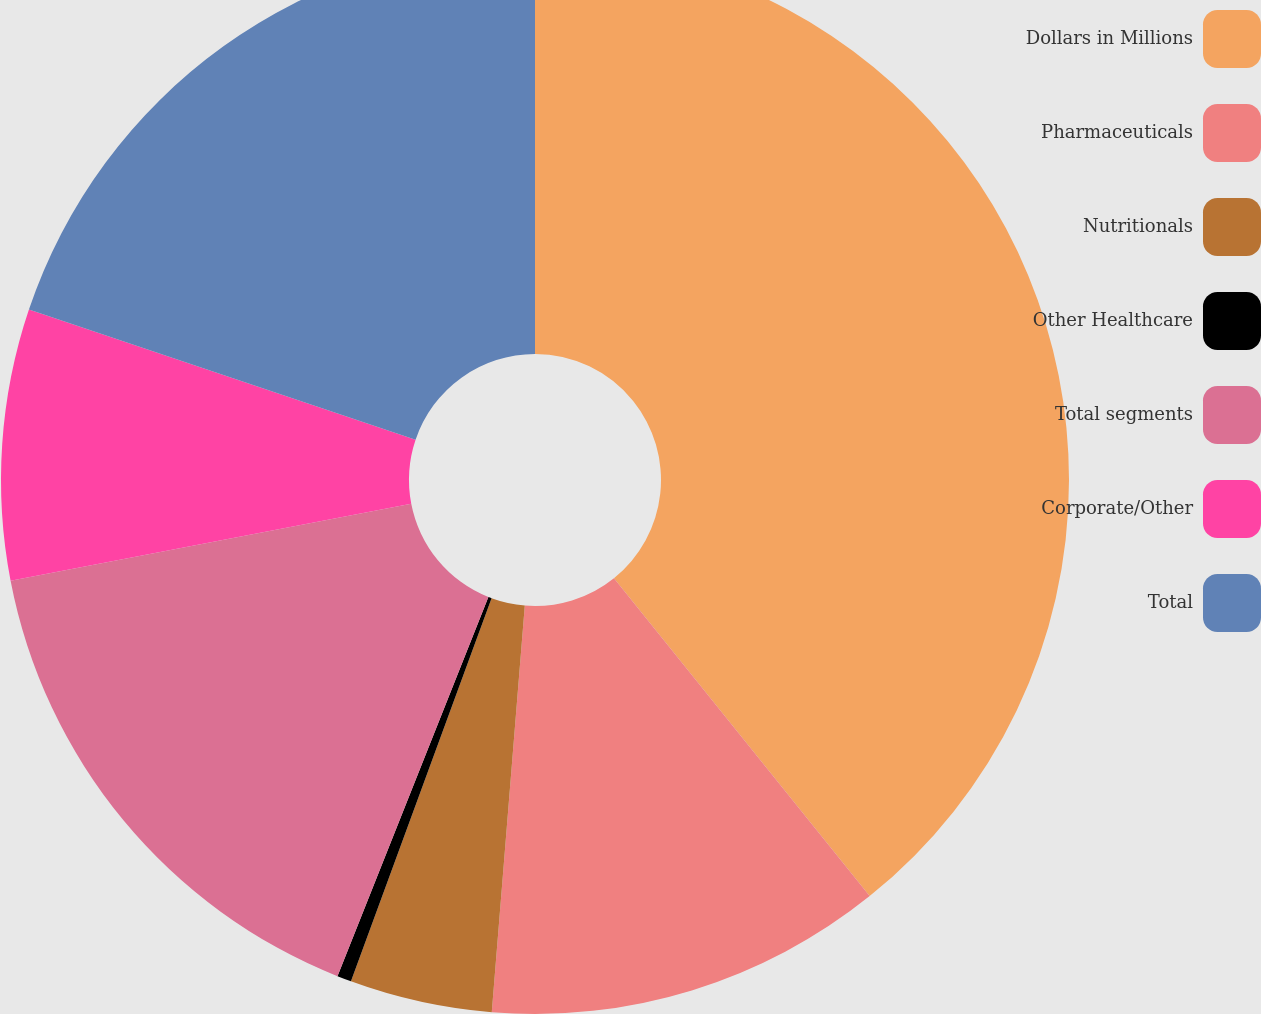<chart> <loc_0><loc_0><loc_500><loc_500><pie_chart><fcel>Dollars in Millions<fcel>Pharmaceuticals<fcel>Nutritionals<fcel>Other Healthcare<fcel>Total segments<fcel>Corporate/Other<fcel>Total<nl><fcel>39.22%<fcel>12.07%<fcel>4.31%<fcel>0.43%<fcel>15.95%<fcel>8.19%<fcel>19.83%<nl></chart> 